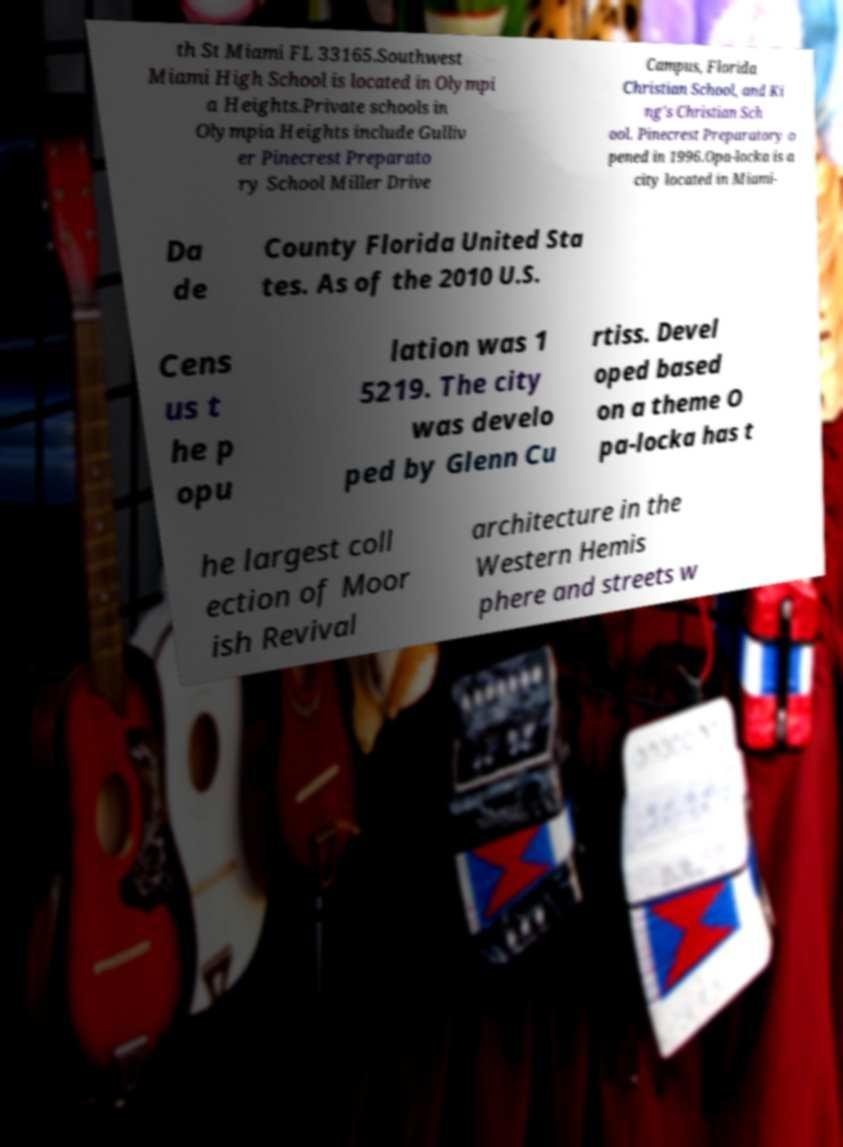Please identify and transcribe the text found in this image. th St Miami FL 33165.Southwest Miami High School is located in Olympi a Heights.Private schools in Olympia Heights include Gulliv er Pinecrest Preparato ry School Miller Drive Campus, Florida Christian School, and Ki ng's Christian Sch ool. Pinecrest Preparatory o pened in 1996.Opa-locka is a city located in Miami- Da de County Florida United Sta tes. As of the 2010 U.S. Cens us t he p opu lation was 1 5219. The city was develo ped by Glenn Cu rtiss. Devel oped based on a theme O pa-locka has t he largest coll ection of Moor ish Revival architecture in the Western Hemis phere and streets w 